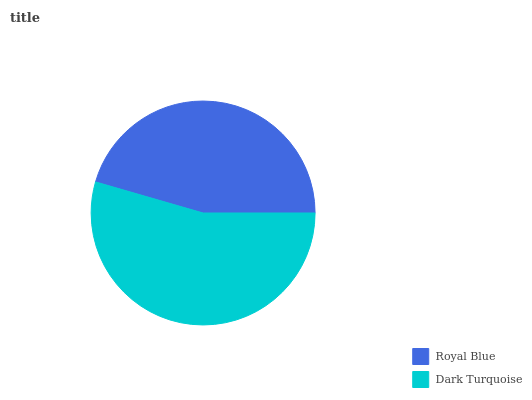Is Royal Blue the minimum?
Answer yes or no. Yes. Is Dark Turquoise the maximum?
Answer yes or no. Yes. Is Dark Turquoise the minimum?
Answer yes or no. No. Is Dark Turquoise greater than Royal Blue?
Answer yes or no. Yes. Is Royal Blue less than Dark Turquoise?
Answer yes or no. Yes. Is Royal Blue greater than Dark Turquoise?
Answer yes or no. No. Is Dark Turquoise less than Royal Blue?
Answer yes or no. No. Is Dark Turquoise the high median?
Answer yes or no. Yes. Is Royal Blue the low median?
Answer yes or no. Yes. Is Royal Blue the high median?
Answer yes or no. No. Is Dark Turquoise the low median?
Answer yes or no. No. 